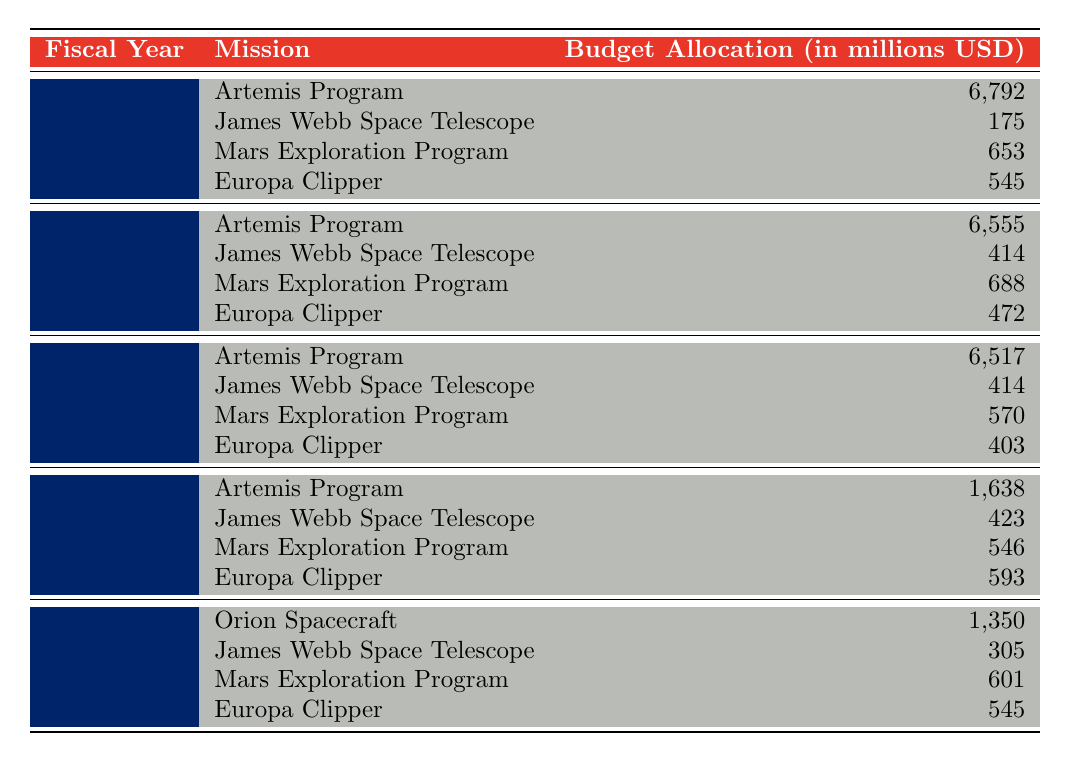What was the budget allocation for the James Webb Space Telescope in 2023? The table shows that the budget allocation for the James Webb Space Telescope in 2023 is 175 million USD.
Answer: 175 million USD Which mission received the highest budget allocation in 2022? Referring to the table, the Artemis Program received the highest budget allocation in 2022, amounting to 6,555 million USD.
Answer: Artemis Program How much more was allocated to the Artemis Program in 2023 compared to 2020? The budget allocation for the Artemis Program in 2023 is 6,792 million USD, and in 2020 it was 1,638 million USD. The difference is 6,792 - 1,638 = 5,154 million USD.
Answer: 5,154 million USD What is the total budget allocation for Mars Exploration Program over the years shown in the table? The budget allocations for the Mars Exploration Program are 653 (2023), 688 (2022), 570 (2021), 546 (2020), and 601 (2019). Adding these amounts gives 653 + 688 + 570 + 546 + 601 = 3,058 million USD.
Answer: 3,058 million USD Did the total budget for James Webb Space Telescope increase from 2020 to 2021? In 2020, the allocation was 423 million USD and in 2021, it remained 414 million USD. Since 414 is less than 423, the total did not increase.
Answer: No What is the average budget allocation for the Europa Clipper over the five years presented? The allocations for Europa Clipper are 545 (2023), 472 (2022), 403 (2021), 593 (2020), and 545 (2019). The total sum is 545 + 472 + 403 + 593 + 545 = 2,658 million USD. There are 5 years, so the average is 2,658 / 5 = 531.6 million USD.
Answer: 531.6 million USD Which year had the lowest total budget allocation for all missions combined? To find the year with the lowest total, we sum the budgets for each year: 2023: 6,792 + 175 + 653 + 545 = 8,165; 2022: 6,555 + 414 + 688 + 472 = 8,129; 2021: 6,517 + 414 + 570 + 403 = 8,904; 2020: 1,638 + 423 + 546 + 593 = 3,200; 2019: 1,350 + 305 + 601 + 545 = 2,801. The lowest total is for the year 2019 with 2,801 million USD.
Answer: 2019 How much was the budget allocation for the Orion Spacecraft in comparison to the Europa Clipper in 2019? In 2019, the Orion Spacecraft received 1,350 million USD, while the Europa Clipper had 545 million USD. The comparison shows that Orion Spacecraft received more: 1,350 - 545 = 805 million USD more than Europa Clipper.
Answer: 805 million USD What is the trend in budget allocation for the Artemis Program from 2020 to 2023? In 2020, the Artemis Program had 1,638 million USD, increased to 6,517 million USD in 2021, 6,555 million USD in 2022, and 6,792 million USD in 2023. The trend shows a steady increase over the years.
Answer: Steady increase Did the Mars Exploration Program ever receive a budget allocation higher than the Europa Clipper in any year? In 2022, the Mars Exploration Program received 688 million USD while the Europa Clipper received 472 million USD; similarly, in 2021, 570 million USD vs. 403 million USD, and in 2023, 653 million USD vs. 545 million USD. Therefore, yes, in all years Mars received more than Europa.
Answer: Yes 